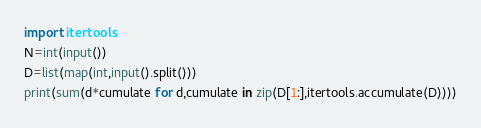Convert code to text. <code><loc_0><loc_0><loc_500><loc_500><_Python_>import itertools
N=int(input())
D=list(map(int,input().split()))
print(sum(d*cumulate for d,cumulate in zip(D[1:],itertools.accumulate(D))))</code> 